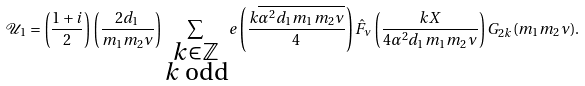<formula> <loc_0><loc_0><loc_500><loc_500>\mathcal { U } _ { 1 } = \left ( \frac { 1 + i } { 2 } \right ) \left ( \frac { 2 d _ { 1 } } { m _ { 1 } m _ { 2 } \nu } \right ) \sum _ { \substack { k \in \mathbb { Z } \\ k \text { odd} } } e \left ( \frac { k \overline { \alpha ^ { 2 } d _ { 1 } m _ { 1 } m _ { 2 } \nu } } { 4 } \right ) \hat { F } _ { \nu } \left ( \frac { k X } { 4 \alpha ^ { 2 } d _ { 1 } m _ { 1 } m _ { 2 } \nu } \right ) G _ { 2 k } ( m _ { 1 } m _ { 2 } \nu ) .</formula> 